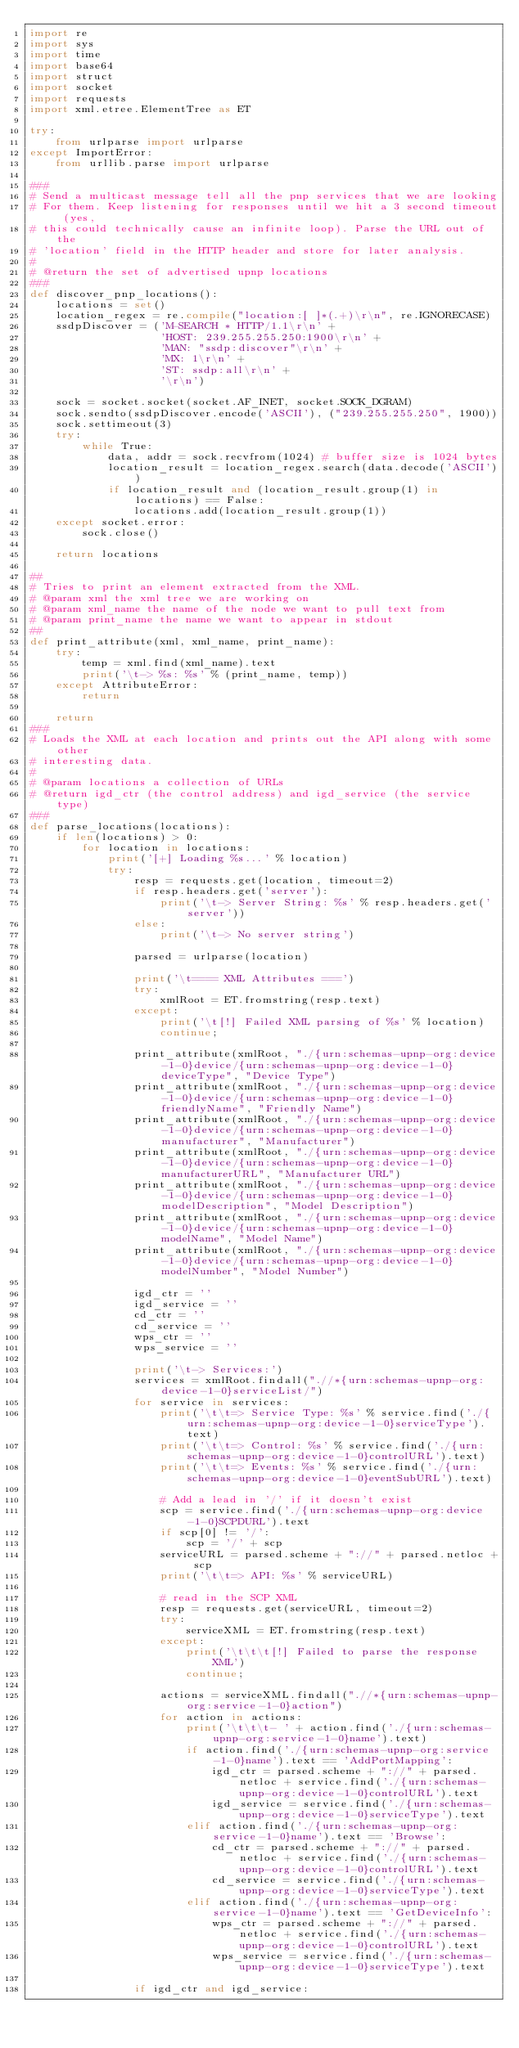<code> <loc_0><loc_0><loc_500><loc_500><_Python_>import re
import sys
import time
import base64
import struct
import socket
import requests
import xml.etree.ElementTree as ET

try:
    from urlparse import urlparse
except ImportError:
    from urllib.parse import urlparse

###
# Send a multicast message tell all the pnp services that we are looking
# For them. Keep listening for responses until we hit a 3 second timeout (yes,
# this could technically cause an infinite loop). Parse the URL out of the
# 'location' field in the HTTP header and store for later analysis.
#
# @return the set of advertised upnp locations
###
def discover_pnp_locations():
    locations = set()
    location_regex = re.compile("location:[ ]*(.+)\r\n", re.IGNORECASE)
    ssdpDiscover = ('M-SEARCH * HTTP/1.1\r\n' +
                    'HOST: 239.255.255.250:1900\r\n' +
                    'MAN: "ssdp:discover"\r\n' +
                    'MX: 1\r\n' +
                    'ST: ssdp:all\r\n' +
                    '\r\n')

    sock = socket.socket(socket.AF_INET, socket.SOCK_DGRAM)
    sock.sendto(ssdpDiscover.encode('ASCII'), ("239.255.255.250", 1900))
    sock.settimeout(3)
    try:
        while True:
            data, addr = sock.recvfrom(1024) # buffer size is 1024 bytes
            location_result = location_regex.search(data.decode('ASCII'))
            if location_result and (location_result.group(1) in locations) == False:
                locations.add(location_result.group(1))
    except socket.error:
        sock.close()

    return locations

##
# Tries to print an element extracted from the XML.
# @param xml the xml tree we are working on
# @param xml_name the name of the node we want to pull text from
# @param print_name the name we want to appear in stdout
##
def print_attribute(xml, xml_name, print_name):
    try:
        temp = xml.find(xml_name).text
        print('\t-> %s: %s' % (print_name, temp))
    except AttributeError:
        return

    return
###
# Loads the XML at each location and prints out the API along with some other
# interesting data.
#
# @param locations a collection of URLs
# @return igd_ctr (the control address) and igd_service (the service type)
###
def parse_locations(locations):
    if len(locations) > 0:
        for location in locations:
            print('[+] Loading %s...' % location)
            try:
                resp = requests.get(location, timeout=2)
                if resp.headers.get('server'):
                    print('\t-> Server String: %s' % resp.headers.get('server'))
                else:
                    print('\t-> No server string')

                parsed = urlparse(location)

                print('\t==== XML Attributes ===')
                try:
                    xmlRoot = ET.fromstring(resp.text)
                except:
                    print('\t[!] Failed XML parsing of %s' % location)
                    continue;

                print_attribute(xmlRoot, "./{urn:schemas-upnp-org:device-1-0}device/{urn:schemas-upnp-org:device-1-0}deviceType", "Device Type")
                print_attribute(xmlRoot, "./{urn:schemas-upnp-org:device-1-0}device/{urn:schemas-upnp-org:device-1-0}friendlyName", "Friendly Name")
                print_attribute(xmlRoot, "./{urn:schemas-upnp-org:device-1-0}device/{urn:schemas-upnp-org:device-1-0}manufacturer", "Manufacturer")
                print_attribute(xmlRoot, "./{urn:schemas-upnp-org:device-1-0}device/{urn:schemas-upnp-org:device-1-0}manufacturerURL", "Manufacturer URL")
                print_attribute(xmlRoot, "./{urn:schemas-upnp-org:device-1-0}device/{urn:schemas-upnp-org:device-1-0}modelDescription", "Model Description")
                print_attribute(xmlRoot, "./{urn:schemas-upnp-org:device-1-0}device/{urn:schemas-upnp-org:device-1-0}modelName", "Model Name")
                print_attribute(xmlRoot, "./{urn:schemas-upnp-org:device-1-0}device/{urn:schemas-upnp-org:device-1-0}modelNumber", "Model Number")

                igd_ctr = ''
                igd_service = ''
                cd_ctr = ''
                cd_service = ''
                wps_ctr = ''
                wps_service = ''

                print('\t-> Services:')
                services = xmlRoot.findall(".//*{urn:schemas-upnp-org:device-1-0}serviceList/")
                for service in services:
                    print('\t\t=> Service Type: %s' % service.find('./{urn:schemas-upnp-org:device-1-0}serviceType').text)
                    print('\t\t=> Control: %s' % service.find('./{urn:schemas-upnp-org:device-1-0}controlURL').text)
                    print('\t\t=> Events: %s' % service.find('./{urn:schemas-upnp-org:device-1-0}eventSubURL').text)

                    # Add a lead in '/' if it doesn't exist
                    scp = service.find('./{urn:schemas-upnp-org:device-1-0}SCPDURL').text
                    if scp[0] != '/':
                        scp = '/' + scp
                    serviceURL = parsed.scheme + "://" + parsed.netloc + scp
                    print('\t\t=> API: %s' % serviceURL)

                    # read in the SCP XML
                    resp = requests.get(serviceURL, timeout=2)
                    try:
                        serviceXML = ET.fromstring(resp.text)
                    except:
                        print('\t\t\t[!] Failed to parse the response XML')
                        continue;

                    actions = serviceXML.findall(".//*{urn:schemas-upnp-org:service-1-0}action")
                    for action in actions:
                        print('\t\t\t- ' + action.find('./{urn:schemas-upnp-org:service-1-0}name').text)
                        if action.find('./{urn:schemas-upnp-org:service-1-0}name').text == 'AddPortMapping':
                            igd_ctr = parsed.scheme + "://" + parsed.netloc + service.find('./{urn:schemas-upnp-org:device-1-0}controlURL').text
                            igd_service = service.find('./{urn:schemas-upnp-org:device-1-0}serviceType').text
                        elif action.find('./{urn:schemas-upnp-org:service-1-0}name').text == 'Browse':
                            cd_ctr = parsed.scheme + "://" + parsed.netloc + service.find('./{urn:schemas-upnp-org:device-1-0}controlURL').text
                            cd_service = service.find('./{urn:schemas-upnp-org:device-1-0}serviceType').text
                        elif action.find('./{urn:schemas-upnp-org:service-1-0}name').text == 'GetDeviceInfo':
                            wps_ctr = parsed.scheme + "://" + parsed.netloc + service.find('./{urn:schemas-upnp-org:device-1-0}controlURL').text
                            wps_service = service.find('./{urn:schemas-upnp-org:device-1-0}serviceType').text

                if igd_ctr and igd_service:</code> 